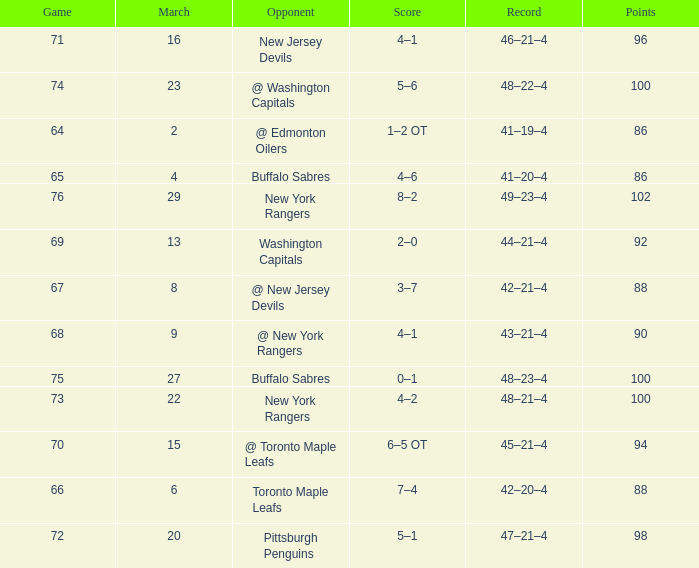Which Points have a Record of 45–21–4, and a Game larger than 70? None. 